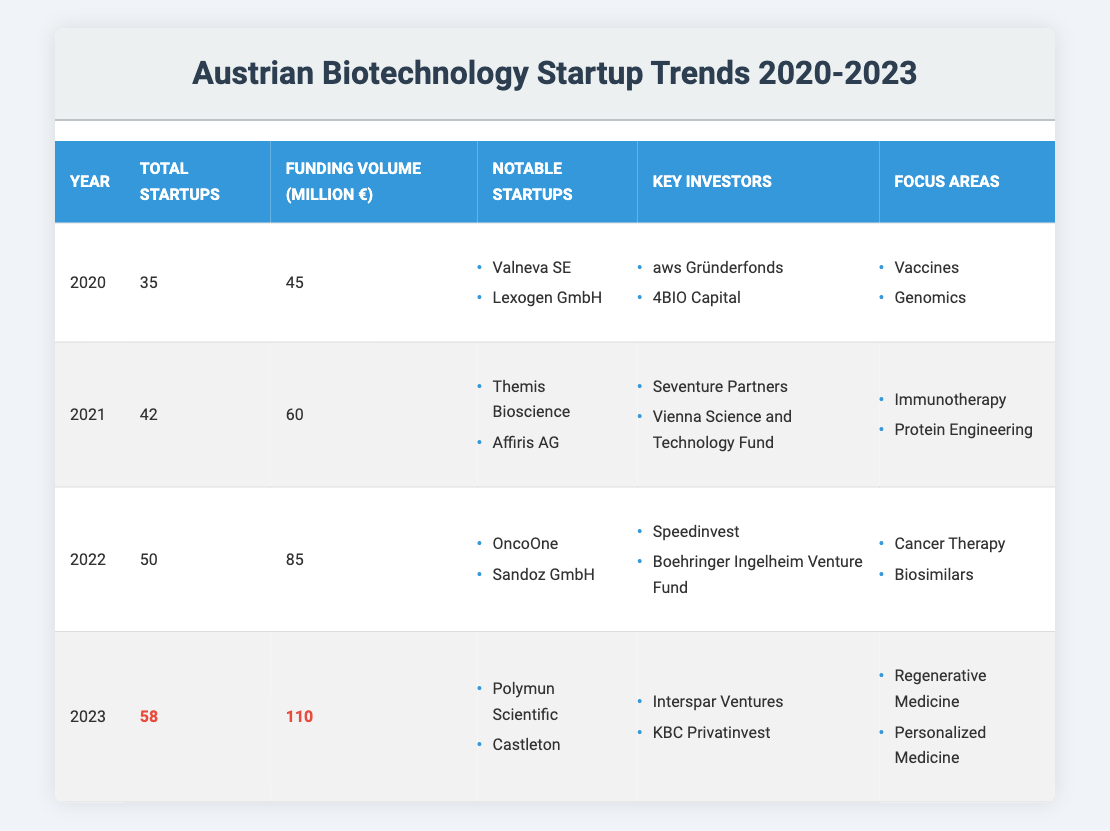What was the total number of startups in 2021? The table shows that the total number of startups in 2021 is listed under the "Total Startups" column for that year, which states 42.
Answer: 42 Which year saw the highest funding volume? By comparing the "Funding Volume (Million €)" column, 2023 has the highest value listed at 110 million euros.
Answer: 2023 How much did the funding volume increase from 2020 to 2022? The funding volumes for 2020 and 2022 are 45 million euros and 85 million euros, respectively. The increase is calculated as 85 - 45 = 40 million euros.
Answer: 40 million euros In which year did biotechnology startups shift their focus to Regenerative Medicine and Personalized Medicine? The focus areas listed for 2023 include Regenerative Medicine and Personalized Medicine, indicating that this shift occurred in that year.
Answer: 2023 Who were the key investors in 2022? The table specifically lists the key investors for 2022 as Speedinvest and Boehringer Ingelheim Venture Fund.
Answer: Speedinvest, Boehringer Ingelheim Venture Fund Which focus area was common between 2021 and 2022? By looking at the focus areas, "Immunotherapy" is unique to 2021, while "Cancer Therapy" is unique to 2022. Thus, there are no common focus areas in those years.
Answer: None What is the average number of startups per year from 2020 to 2023? To calculate the average, sum the total startups from each year: (35 + 42 + 50 + 58) = 185. There are 4 years, so the average is 185 / 4 = 46.25.
Answer: 46.25 Which year experienced the lowest total startups and what was that number? Looking at the "Total Startups" column, 2020 has the lowest count at 35 startups.
Answer: 2020, 35 How many notable startups were listed in 2023? The notable startups listed for 2023 are Polymun Scientific and Castleton, which totals to 2 notable startups for that year.
Answer: 2 Did the number of startups increase every year from 2020 to 2023? By reviewing each year's total startups, the numbers are 35 (2020), 42 (2021), 50 (2022), and 58 (2023), which confirms there was an increase each year, making it true.
Answer: Yes Which year's funding volume was less than 70 million euros? The only funding volumes lower than 70 million euros are from 2020 (45 million euros) and 2021 (60 million euros).
Answer: 2020, 2021 If the funding volume continues to increase at the same rate from 2022 to 2023, what would the expected funding volume be in 2024? The increase in funding from 2022 to 2023 was 110 - 85 = 25 million euros. If this trend continues, the expected funding for 2024 would be 110 + 25 = 135 million euros.
Answer: 135 million euros 